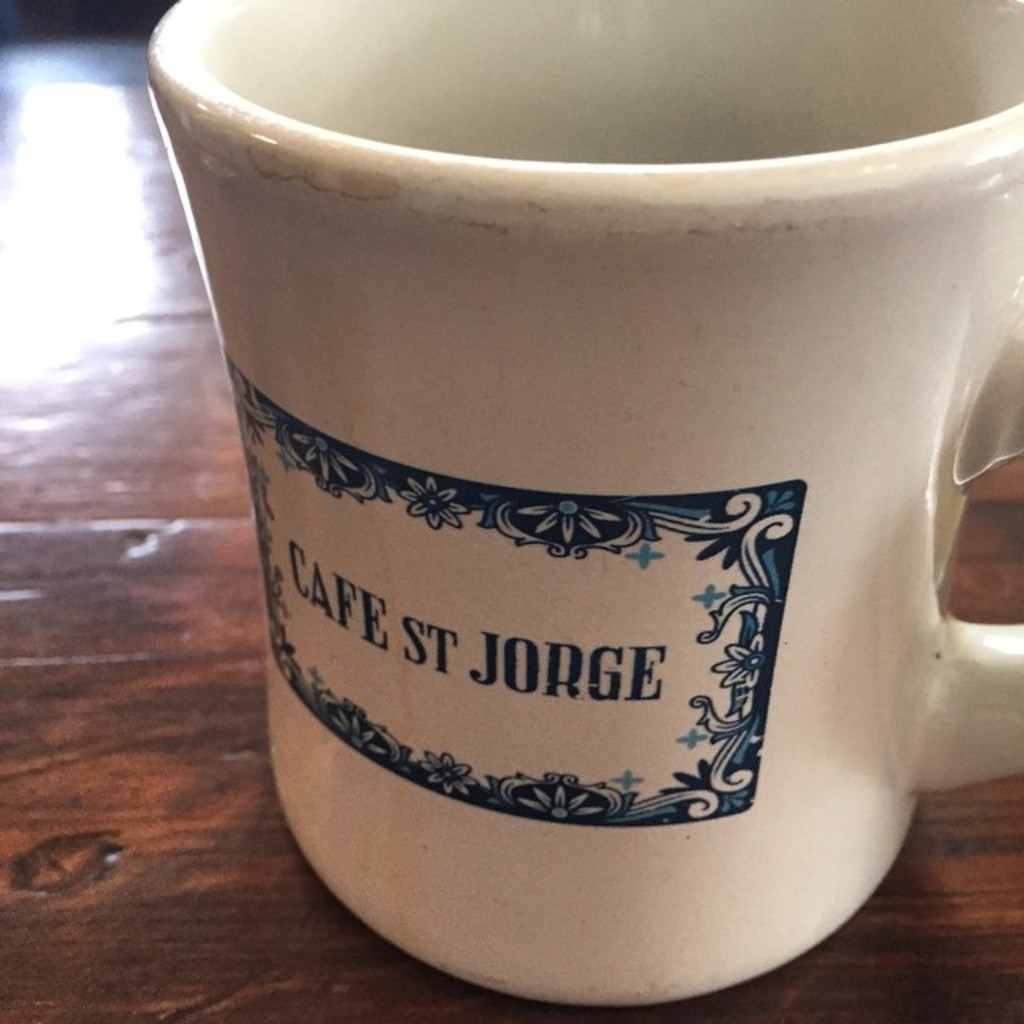Provide a one-sentence caption for the provided image. The image shows a close-up of a charming ceramic mug bearing the inscription 'Cafe ST Jorge,' accentuated with intricate blue floral patterns which add a vintage aesthetic. 